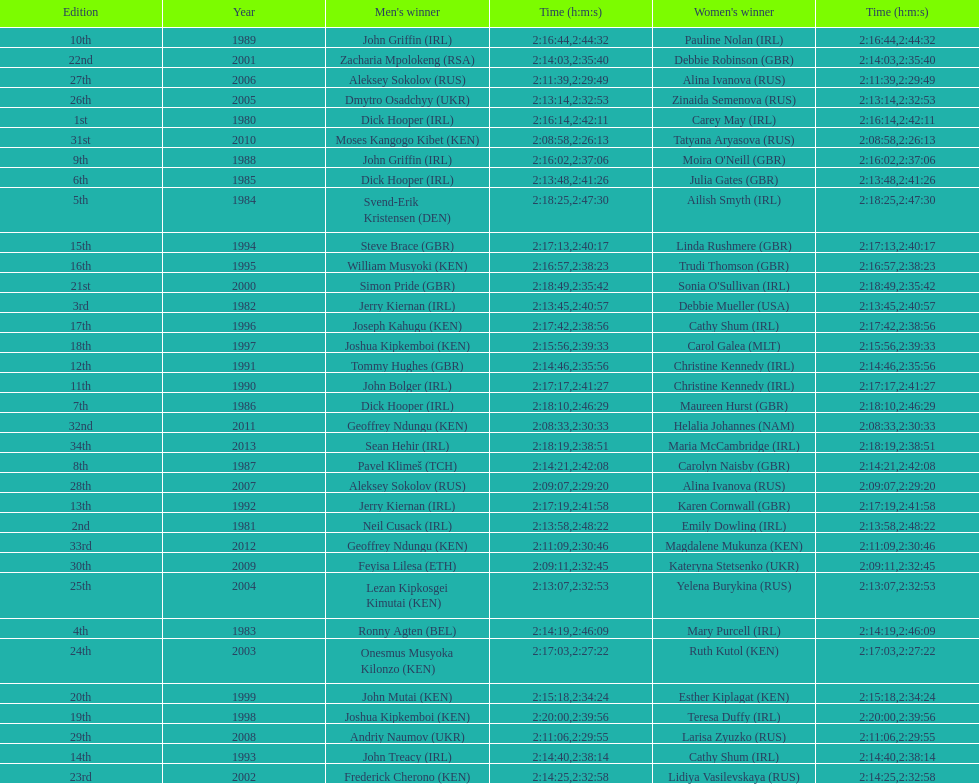In 2009, which competitor finished faster - the male or the female? Male. 